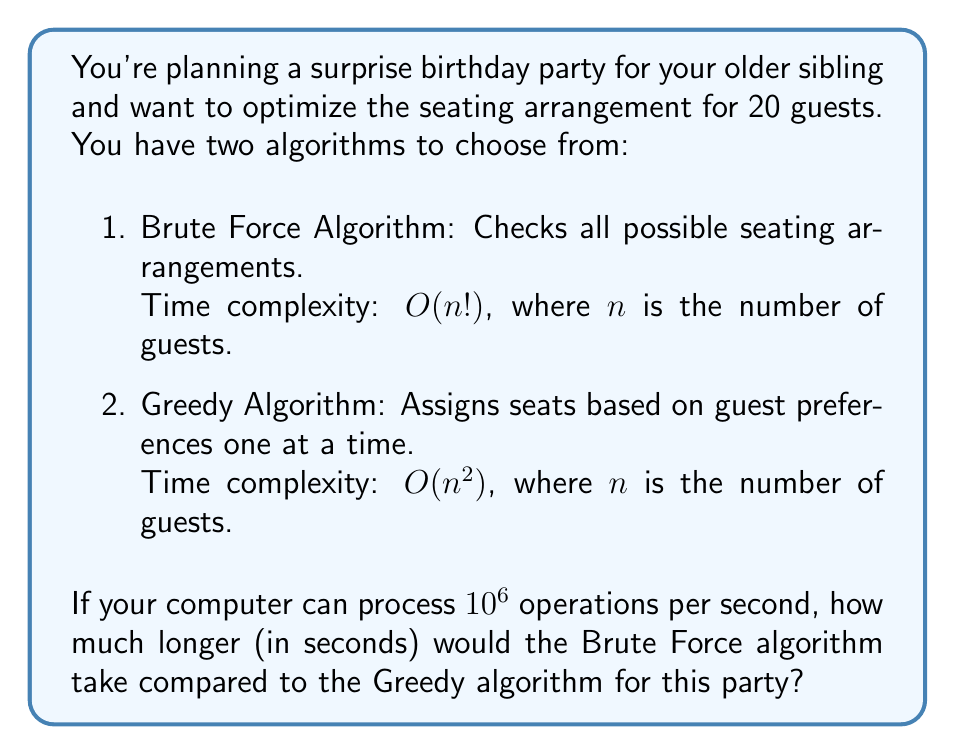What is the answer to this math problem? Let's break this down step-by-step:

1. Calculate the number of operations for the Brute Force algorithm:
   $n! = 20! \approx 2.43 \times 10^{18}$ operations

2. Calculate the number of operations for the Greedy algorithm:
   $n^2 = 20^2 = 400$ operations

3. Calculate the time taken by the Brute Force algorithm:
   Time = $\frac{2.43 \times 10^{18}}{10^6}$ seconds $= 2.43 \times 10^{12}$ seconds

4. Calculate the time taken by the Greedy algorithm:
   Time = $\frac{400}{10^6}$ seconds $= 0.0004$ seconds

5. Calculate the difference in time:
   Difference = $2.43 \times 10^{12} - 0.0004 \approx 2.43 \times 10^{12}$ seconds

The difference is approximately $2.43 \times 10^{12}$ seconds, which is about 77,000 years. This demonstrates the vast difference in efficiency between these two algorithms for this problem size.
Answer: $2.43 \times 10^{12}$ seconds 